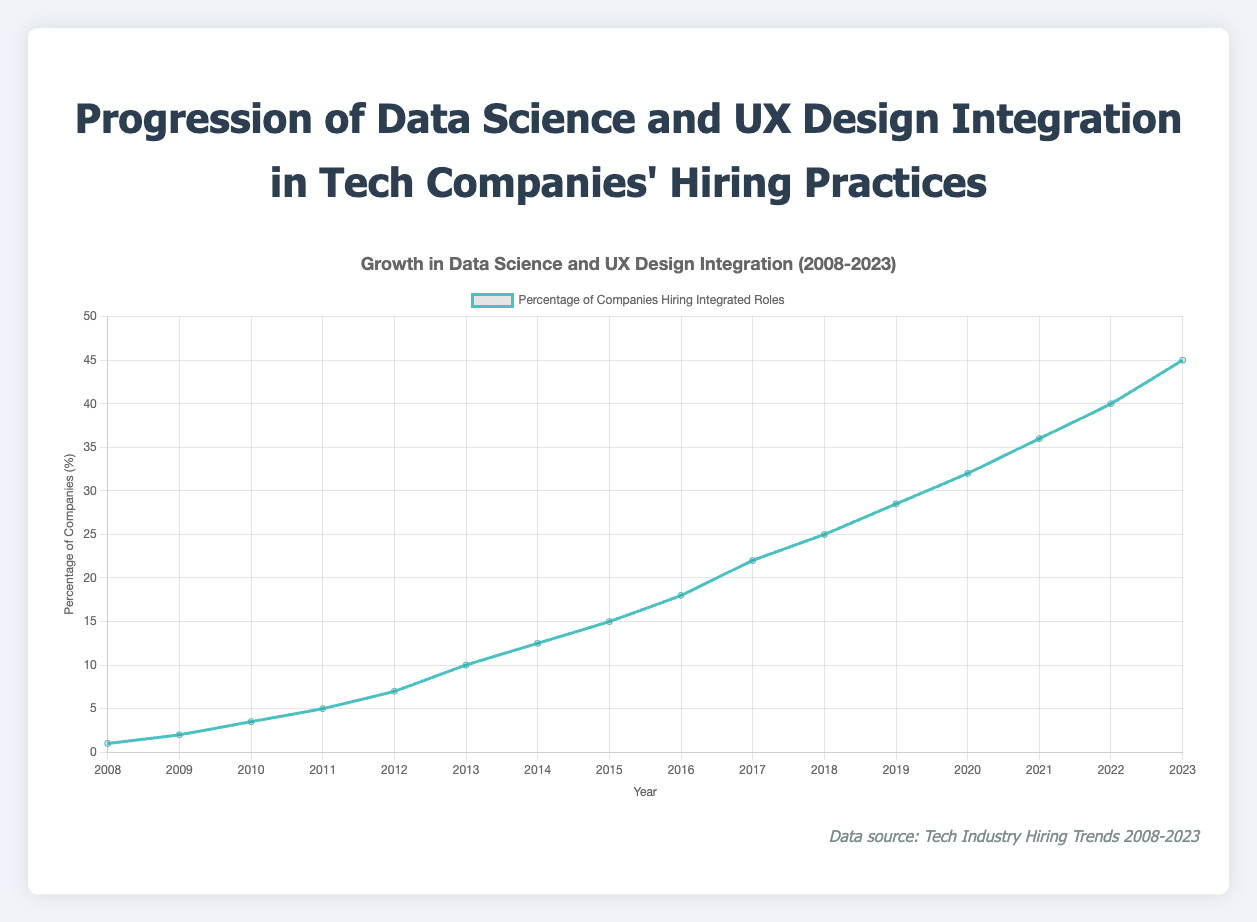What is the overall trend of the percentage of companies hiring integrated roles from 2008 to 2023? The overall trend shows a steady increase in the percentage of companies hiring integrated roles over the 15-year period. The line graph consistently rises from 1.0% in 2008 to 45.0% in 2023, indicating growing integration of data science and UX design in hiring practices.
Answer: Steady increase Which year saw the greatest percentage increase in companies hiring integrated roles compared to the previous year? To find this, compare the percentage increase year-over-year. The largest jump is from 2013 to 2014, where the percentage increased from 10.0% to 12.5%, registering a 2.5% increase.
Answer: 2014 How many years did it take for the percentage of companies hiring integrated roles to double from 5%? In 2011, the percentage was 5.0%. The percentage doubled to 10.0% by 2013. Therefore, it took 2 years (from 2011 to 2013).
Answer: 2 years Compare the hiring percentage between 2010 and 2020. What is the difference? In 2010, the percentage of companies hiring integrated roles was 3.5%. In 2020, it was 32.0%. The difference is calculated as 32.0% - 3.5% = 28.5%.
Answer: 28.5% In which year did the percentage of companies hiring integrated roles first reach or exceed 20%? From the plot, the first year where the percentage reached or exceeded 20% is 2017, with a percentage of 22.0%.
Answer: 2017 What notable event coincided with a significant rise in companies hiring integrated roles in 2017? According to the tooltip information added in the visual, the notable event in 2017 was "Growth of AI and Machine Learning" when the hiring rate rose significantly to 22.0%.
Answer: Growth of AI and Machine Learning What is the average percentage of companies hiring integrated roles over the first five years (2008-2012)? To find the average, add the percentages for each year from 2008 to 2012 and then divide by the number of years. The sum is 1.0 + 2.0 + 3.5 + 5.0 + 7.0 = 18.5%. The average is 18.5 / 5 = 3.7%.
Answer: 3.7% Identify two companies involved in hiring integrated roles in both 2008 and 2023? The plot provides examples of companies for each year. IBM and Microsoft are involved both in 2008 and 2023.
Answer: IBM, Microsoft Which year showed the smallest rise in the percentage of companies hiring integrated roles compared to the previous year? To find the smallest rise, look at the year-over-year increases. The smallest rise is from 2009 to 2010, increasing just by 1.5% (2.0% to 3.5%).
Answer: 2010 What visual color is used to represent the data line for the percentage of companies hiring integrated roles? The visual color of the line representing the data is light blue, as described in the prompt.
Answer: Light blue 